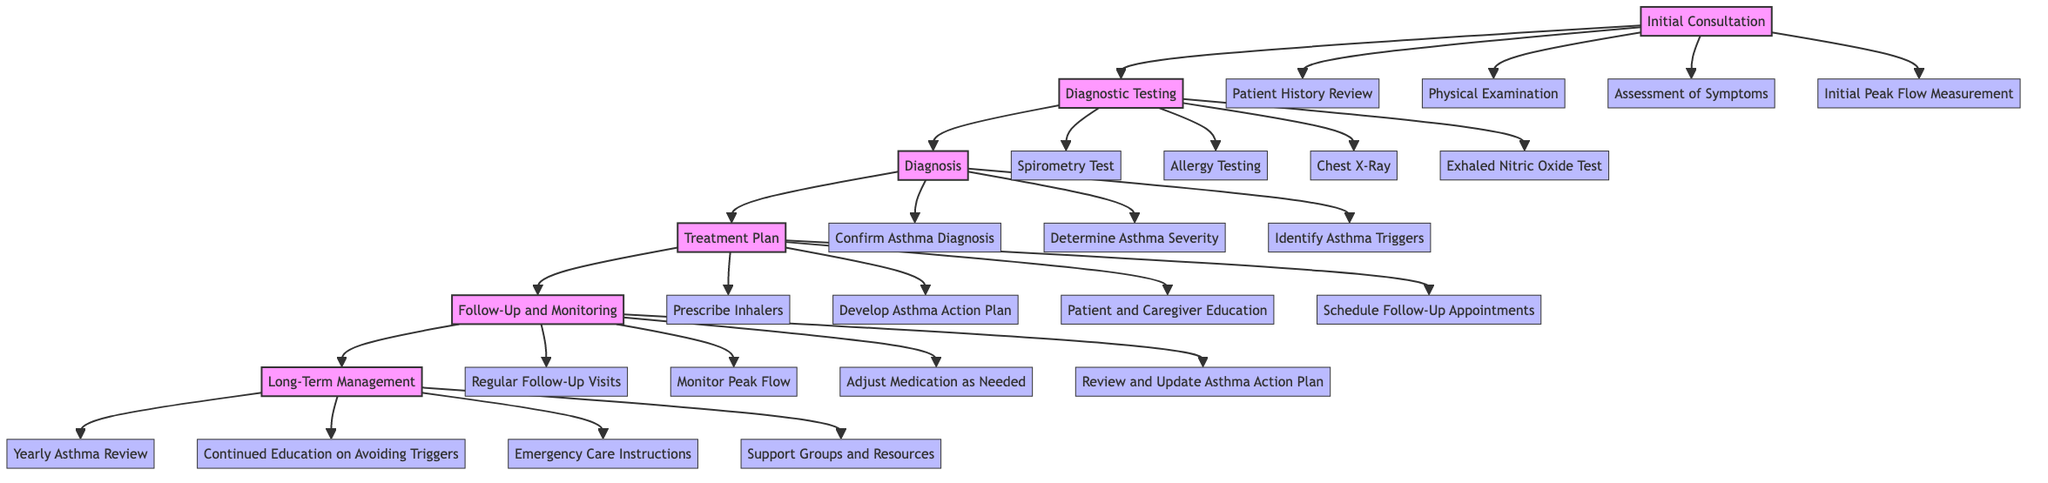what is the first stage in the pathway? The first stage is labeled "Initial Consultation" in the diagram, which visualizes the progression of pediatric asthma care.
Answer: Initial Consultation how many steps are involved in the Treatment Plan stage? The Treatment Plan stage consists of four specific steps, as indicated in the flowchart.
Answer: 4 which stage follows the Diagnosis stage? The stage that comes after Diagnosis is indicated as Treatment Plan in the pathway flow, showing the sequence of care.
Answer: Treatment Plan what is one of the steps under Follow-Up and Monitoring? One of the steps listed under Follow-Up and Monitoring is to "Monitor Peak Flow," part of the continuous care process for asthma management.
Answer: Monitor Peak Flow what are the two last steps in the Long-Term Management? The last two steps listed in the Long-Term Management stage are "Emergency Care Instructions" and "Support Groups and Resources," emphasizing ongoing support.
Answer: Emergency Care Instructions, Support Groups and Resources how many total stages are there in the pathway? The diagram shows a total of six distinct stages in the pediatric asthma care pathway, reflecting comprehensive management steps.
Answer: 6 which diagnostic test is mentioned after Allergy Testing? The diagram clearly outlines that the step following Allergy Testing is the "Chest X-Ray," a part of the Diagnostic Testing stage.
Answer: Chest X-Ray what is the purpose of the Asthma Action Plan in the Treatment Plan stage? The Asthma Action Plan aims to provide clear guidelines for both patients and caregivers to manage asthma effectively, as highlighted in the Treatment Plan stage.
Answer: Develop Asthma Action Plan what is an example of a step in the Initial Consultation stage? An example step from the Initial Consultation stage is "Patient History Review," an important first step in evaluating asthma symptoms.
Answer: Patient History Review 